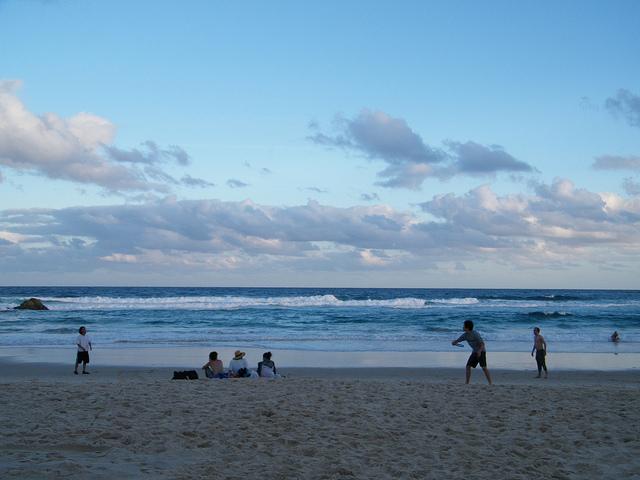Is the ocean in front of them?
Be succinct. Yes. What are they carrying?
Concise answer only. Frisbee. What are the people on the left about to do?
Keep it brief. Catch frisbee. How many people are visible in this scene?
Short answer required. 7. Are there clouds in the sky?
Write a very short answer. Yes. 